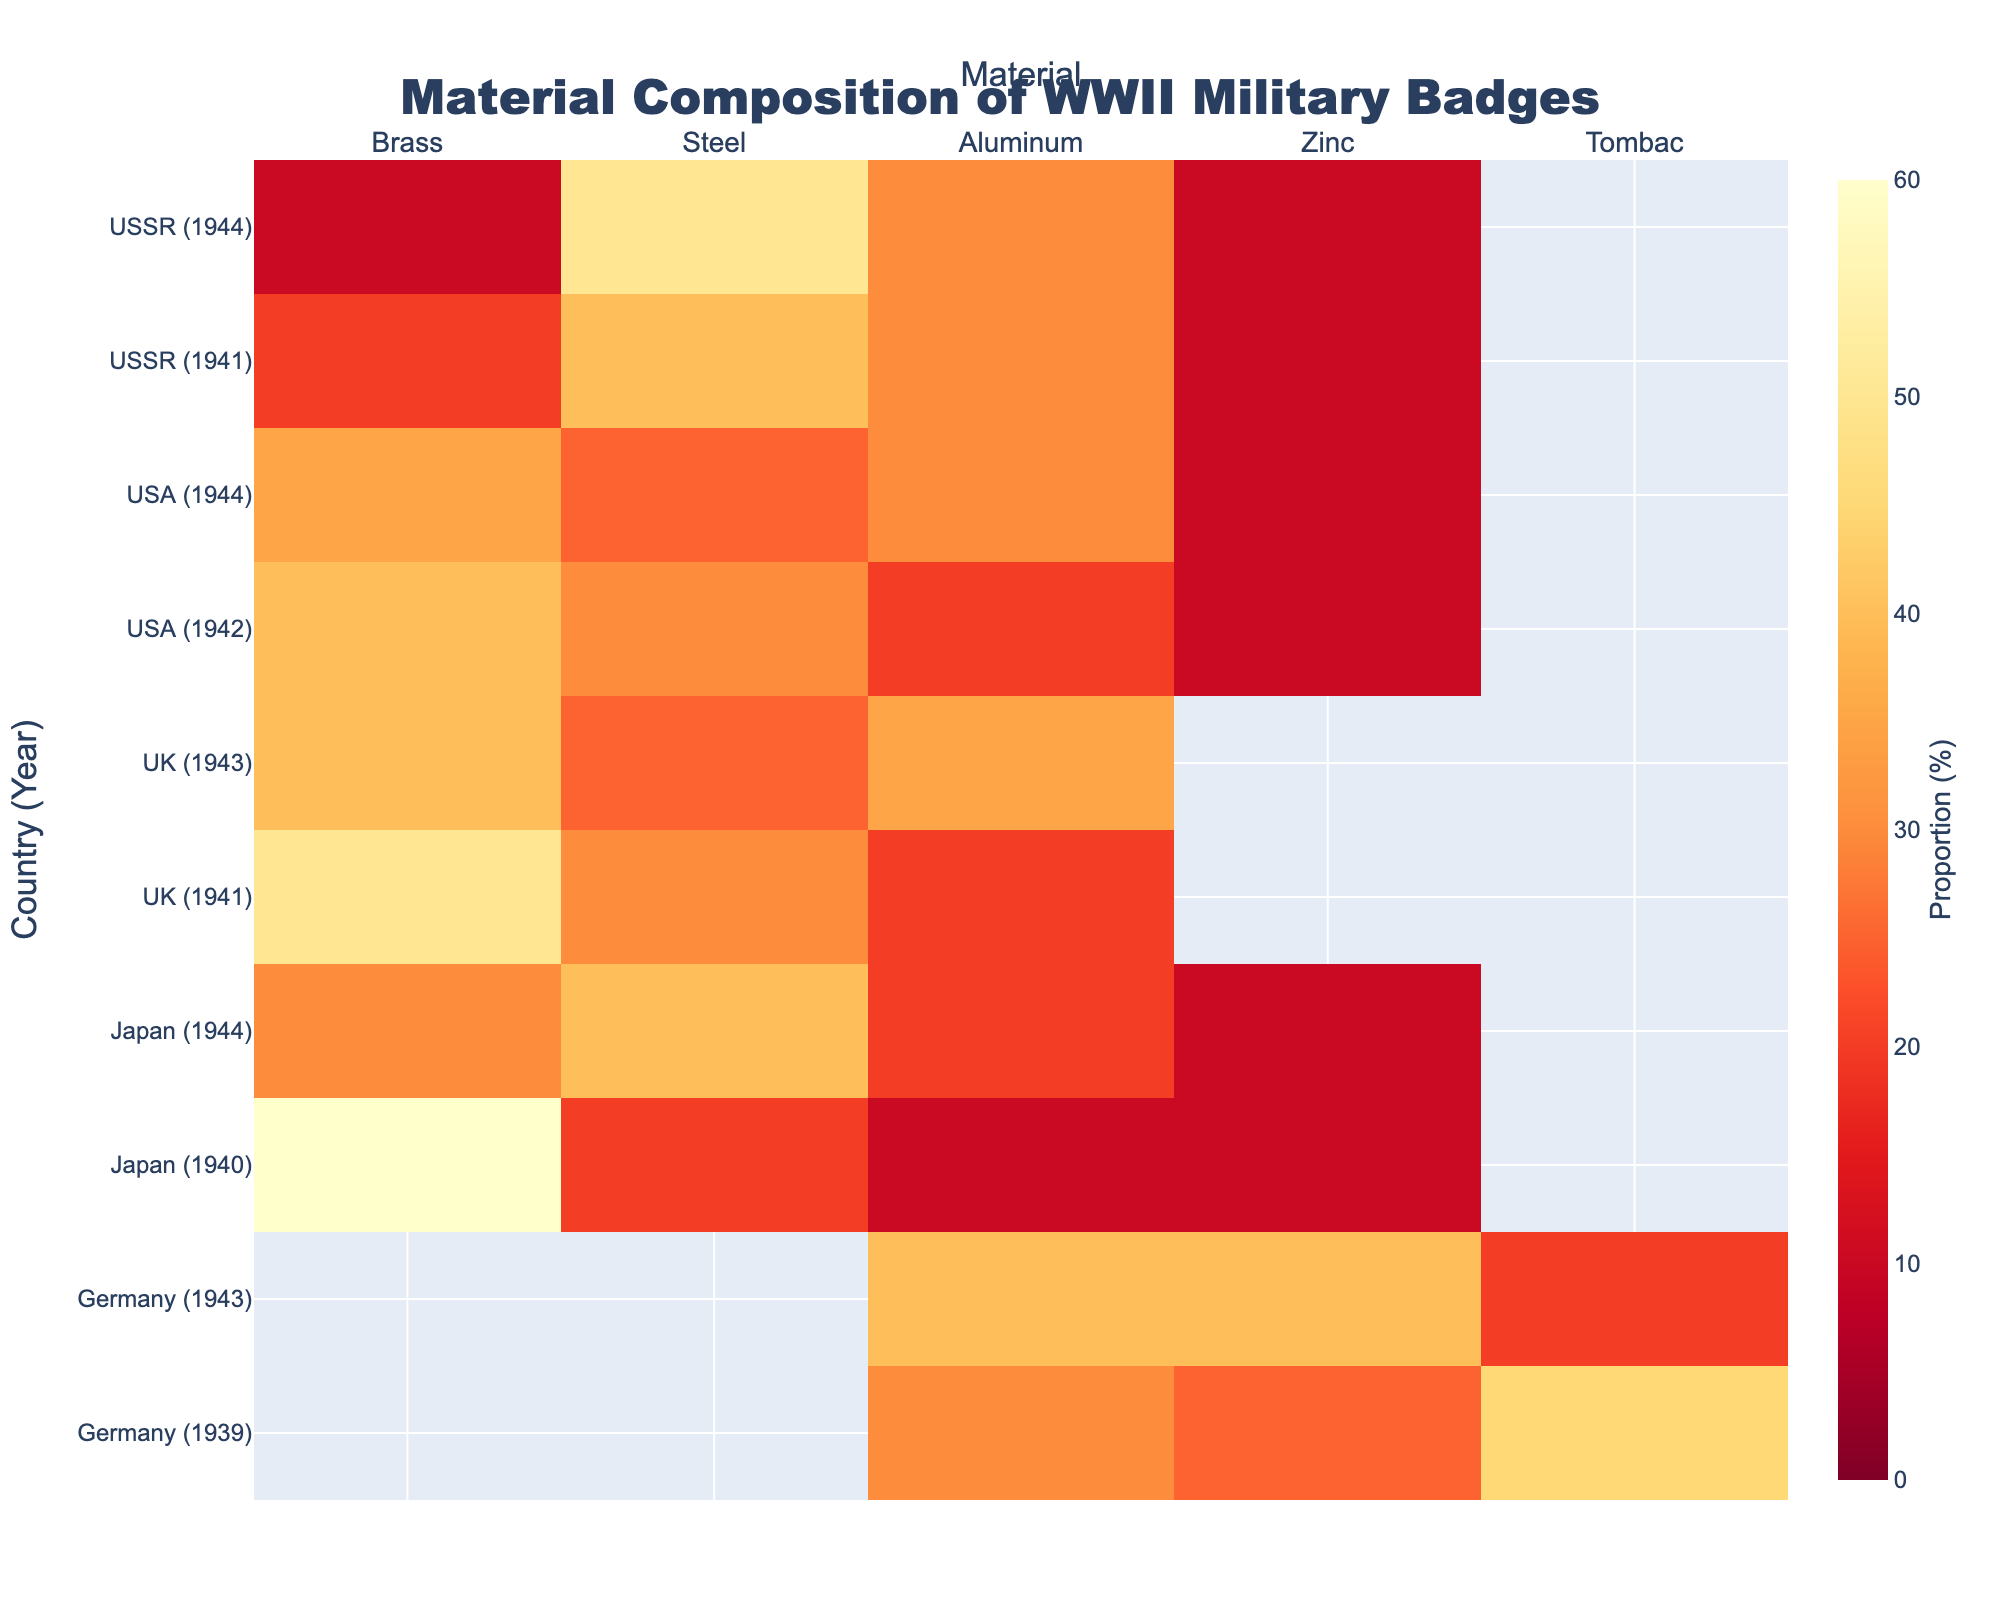How many different materials are shown in the heatmap? The x-axis of the heatmap indicates the different materials being shown. By counting the labels on the x-axis, we find the materials: Brass, Steel, Aluminum, Zinc, and Tombac.
Answer: 5 What country and year combination had the highest proportion of Brass in their military badges? We need to look for the highest value in the 'Brass' column. According to the data, the highest proportion for Brass is 60%, which corresponds to Japan in 1940.
Answer: Japan (1940) In which year did Germany primarily use Aluminum in their badges? Focus on the 'Germany' rows and scan for the highest proportion in the 'Aluminum' column. The highest proportion is 40%, occurring in 1943.
Answer: 1943 Compare the proportion of Steel used in the UK in 1941 and 1943. Which year had the higher proportion? Examine the rows for UK and locate the columns for Steel. In 1941, the proportion is 30%, and in 1943, it is 25%. Therefore, the higher proportion is in 1941.
Answer: 1941 What's the average proportion of Zinc in Japanese badges across the shown years? Identify the proportions of Zinc in the 'Japan' rows for the specified years (1940 and 1944), which are 10% and 10%. Calculate the average: (10 + 10)/2 = 10%.
Answer: 10% Which country had the most diverse material composition in a single year, and what year was it? 'Diverse material composition' implies a more evenly distributed proportion across different materials. Check each country-year combination to see the smallest difference between the highest and lowest values. Germany in 1943 has relatively balanced proportions: 20%, 40%, and 40%.
Answer: Germany (1943) Between 1941 and 1944, did the proportion of Aluminum in the USA military badges increase, decrease, or remain the same? Look at the USA rows for 1942 and 1944 in the Aluminum column. The values are 20% in 1942 and 30% in 1944. This indicates an increase.
Answer: Increase Which material was exclusively used in Germany but not in any other country during the observed years? By examining the presence of materials across countries, Tombac appears only in Germany (1939 and 1943) and not in any other countries listed.
Answer: Tombac 